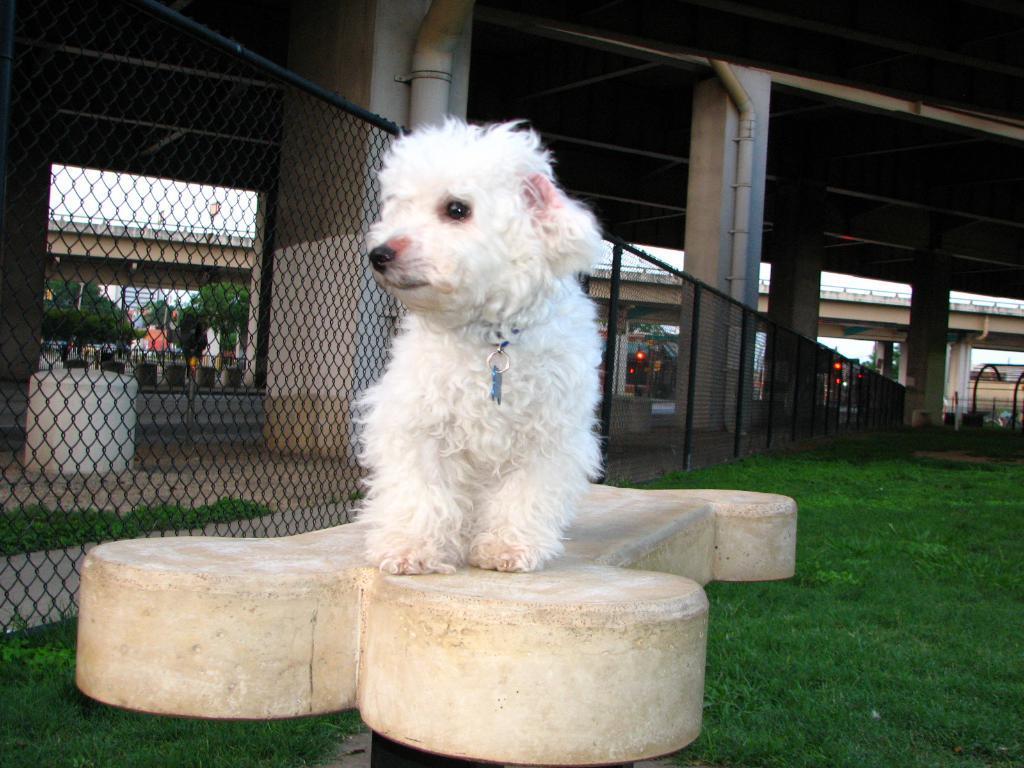Can you describe this image briefly? There is a white color dog, which is standing on the cement stone which is in bone shape and is on the pole, which is on the grass on the ground. In the background, there is fencing, there are pillars of a bridge, there is bridge, there are trees, there are buildings and there are other objects. 